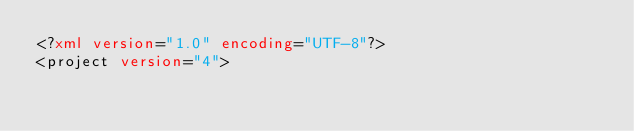<code> <loc_0><loc_0><loc_500><loc_500><_XML_><?xml version="1.0" encoding="UTF-8"?>
<project version="4"></code> 